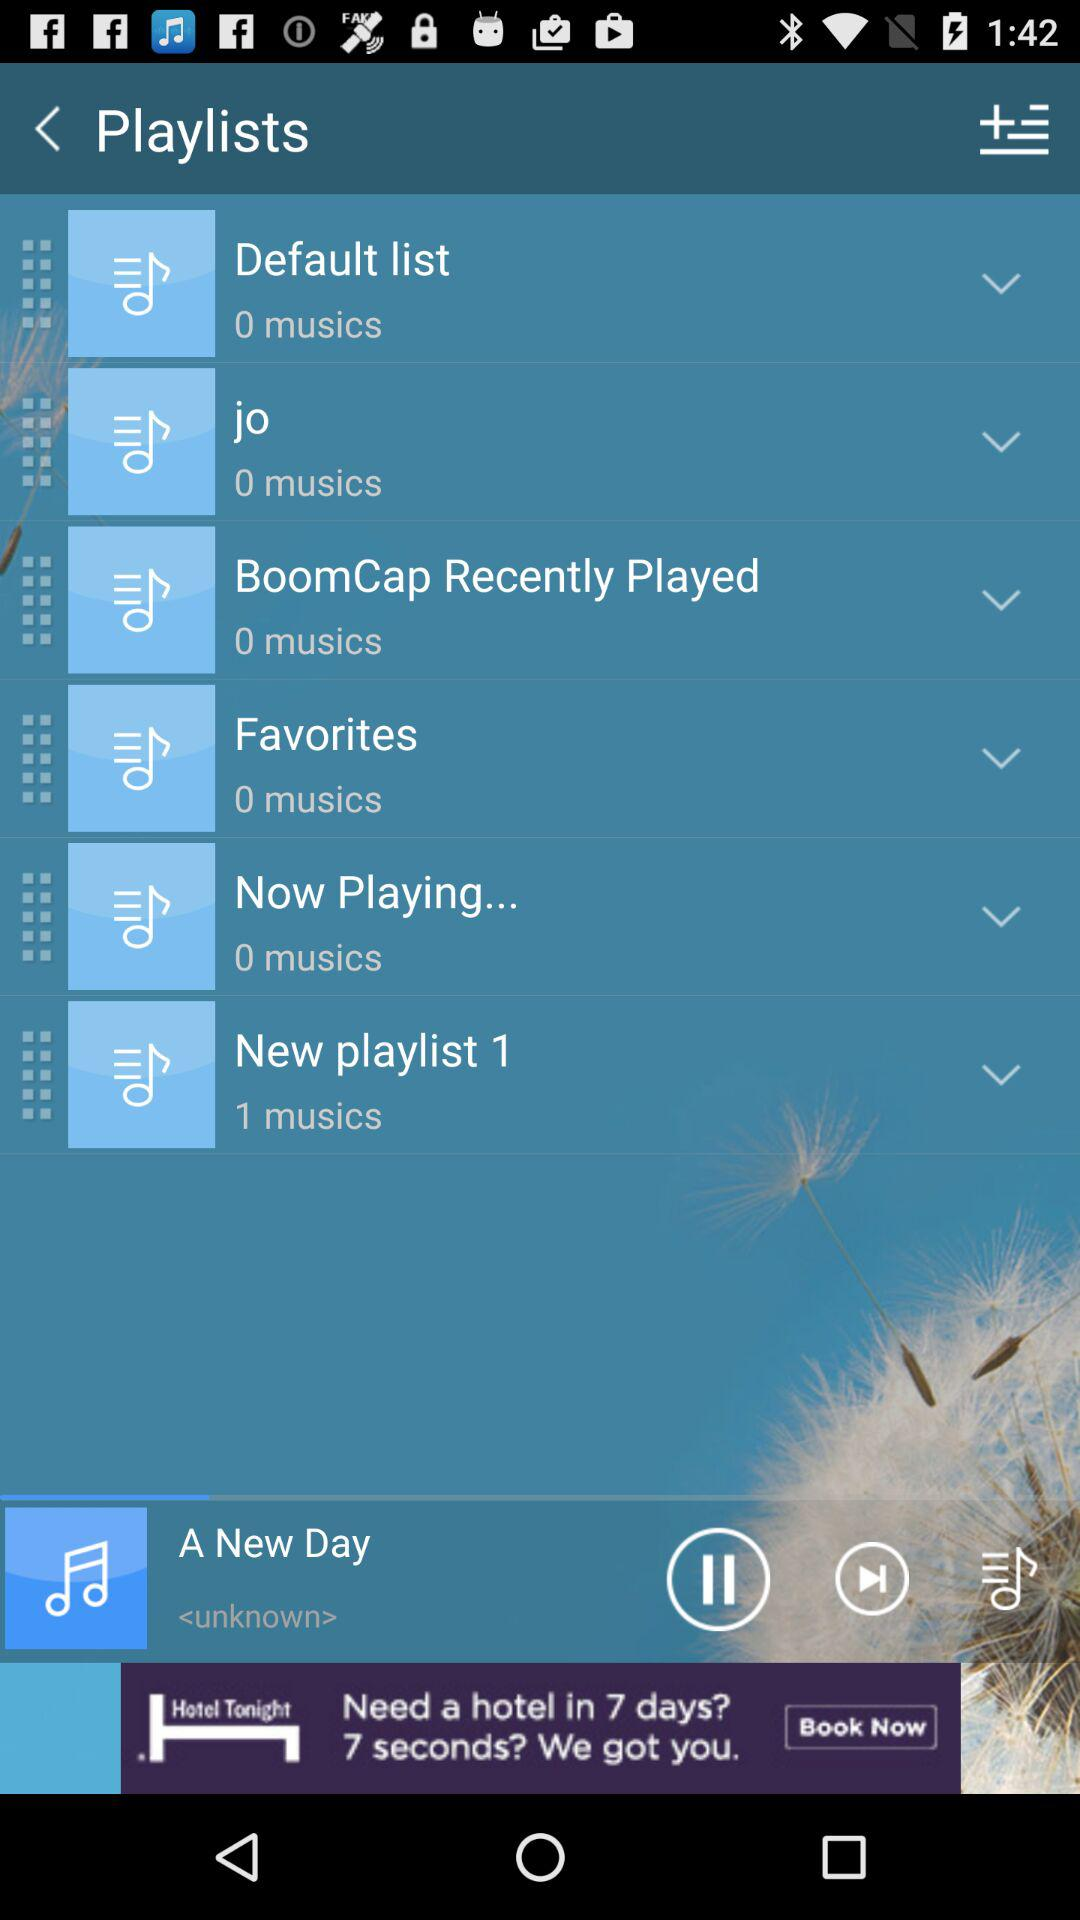How many music are in the "Default list"? There is 0 music in the "Default list". 